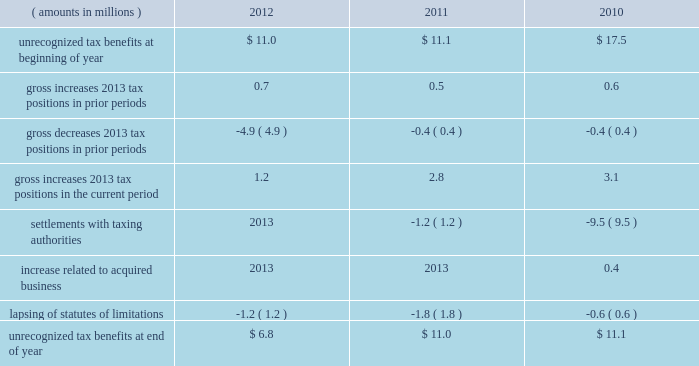A valuation allowance totaling $ 43.9 million , $ 40.4 million and $ 40.1 million as of 2012 , 2011 and 2010 year end , respectively , has been established for deferred income tax assets primarily related to certain subsidiary loss carryforwards that may not be realized .
Realization of the net deferred income tax assets is dependent on generating sufficient taxable income prior to their expiration .
Although realization is not assured , management believes it is more- likely-than-not that the net deferred income tax assets will be realized .
The amount of the net deferred income tax assets considered realizable , however , could change in the near term if estimates of future taxable income during the carryforward period fluctuate .
The following is a reconciliation of the beginning and ending amounts of unrecognized tax benefits for 2012 , 2011 and ( amounts in millions ) 2012 2011 2010 .
Of the $ 6.8 million , $ 11.0 million and $ 11.1 million of unrecognized tax benefits as of 2012 , 2011 and 2010 year end , respectively , approximately $ 4.1 million , $ 9.1 million and $ 11.1 million , respectively , would impact the effective income tax rate if recognized .
Interest and penalties related to unrecognized tax benefits are recorded in income tax expense .
During 2012 and 2011 , the company reversed a net $ 0.5 million and $ 1.4 million , respectively , of interest and penalties to income associated with unrecognized tax benefits .
As of 2012 , 2011 and 2010 year end , the company has provided for $ 1.6 million , $ 1.6 million and $ 2.8 million , respectively , of accrued interest and penalties related to unrecognized tax benefits .
The unrecognized tax benefits and related accrued interest and penalties are included in 201cother long-term liabilities 201d on the accompanying consolidated balance sheets .
Snap-on and its subsidiaries file income tax returns in the united states and in various state , local and foreign jurisdictions .
It is reasonably possible that certain unrecognized tax benefits may either be settled with taxing authorities or the statutes of limitations for such items may lapse within the next 12 months , causing snap-on 2019s gross unrecognized tax benefits to decrease by a range of zero to $ 2.4 million .
Over the next 12 months , snap-on anticipates taking uncertain tax positions on various tax returns for which the related tax benefit does not meet the recognition threshold .
Accordingly , snap-on 2019s gross unrecognized tax benefits may increase by a range of zero to $ 1.6 million over the next 12 months for uncertain tax positions expected to be taken in future tax filings .
With few exceptions , snap-on is no longer subject to u.s .
Federal and state/local income tax examinations by tax authorities for years prior to 2008 , and snap-on is no longer subject to non-u.s .
Income tax examinations by tax authorities for years prior to 2006 .
The undistributed earnings of all non-u.s .
Subsidiaries totaled $ 492.2 million , $ 416.4 million and $ 386.5 million as of 2012 , 2011 and 2010 year end , respectively .
Snap-on has not provided any deferred taxes on these undistributed earnings as it considers the undistributed earnings to be permanently invested .
Determination of the amount of unrecognized deferred income tax liability related to these earnings is not practicable .
2012 annual report 83 .
What was the average unrecognized tax benefits at end of year from 2010 to 2012? 
Computations: ((11.1 + (6.8 + 11.0)) / 3)
Answer: 9.63333. 